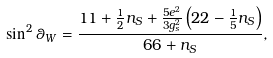<formula> <loc_0><loc_0><loc_500><loc_500>\sin ^ { 2 } \theta _ { W } = \frac { 1 1 + \frac { 1 } { 2 } n _ { S } + \frac { 5 e ^ { 2 } } { 3 g _ { s } ^ { 2 } } \left ( 2 2 - \frac { 1 } { 5 } n _ { S } \right ) } { 6 6 + n _ { S } } ,</formula> 